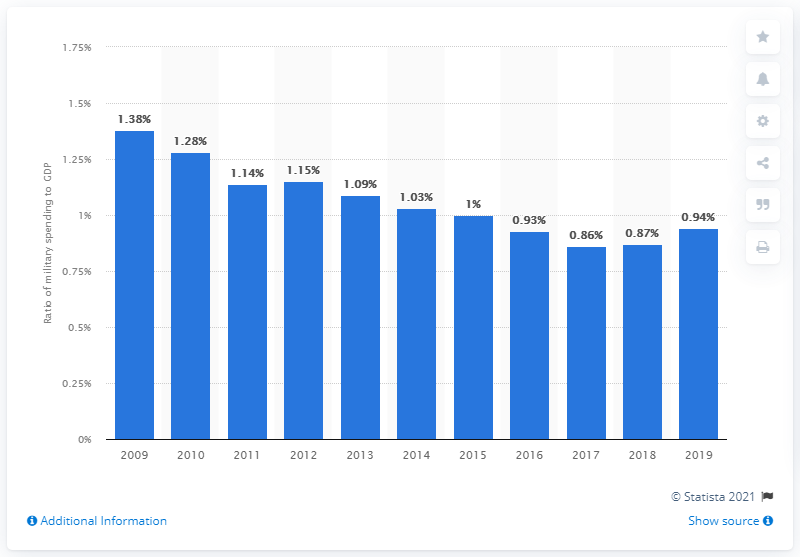Specify some key components in this picture. In 2019, military expenditure in Bosnia and Herzegovina accounted for 9.4% of its Gross Domestic Product (GDP). 